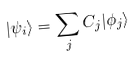Convert formula to latex. <formula><loc_0><loc_0><loc_500><loc_500>| \psi _ { i } \rangle = \sum _ { j } C _ { j } | \phi _ { j } \rangle</formula> 